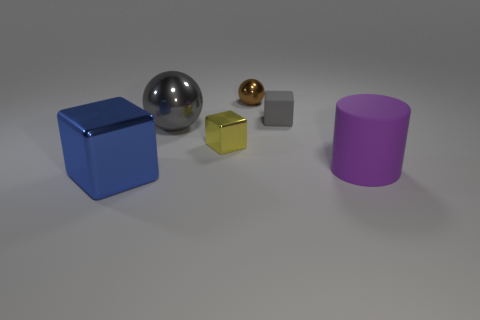What number of blue metal things are the same shape as the gray matte object?
Make the answer very short. 1. There is a matte object that is the same size as the yellow metallic cube; what shape is it?
Ensure brevity in your answer.  Cube. There is a gray metallic object; are there any metal objects behind it?
Provide a succinct answer. Yes. There is a block that is to the right of the brown object; is there a tiny shiny object that is in front of it?
Make the answer very short. Yes. Is the number of big blue things in front of the big block less than the number of metallic blocks that are behind the large cylinder?
Give a very brief answer. Yes. What shape is the brown thing?
Offer a very short reply. Sphere. What is the material of the ball that is on the right side of the big metal sphere?
Give a very brief answer. Metal. There is a sphere that is on the left side of the small metallic object in front of the large thing that is behind the yellow metallic object; what size is it?
Keep it short and to the point. Large. Does the large thing to the right of the tiny brown ball have the same material as the gray object on the right side of the brown shiny sphere?
Ensure brevity in your answer.  Yes. How many other objects are the same color as the small metallic ball?
Provide a short and direct response. 0. 